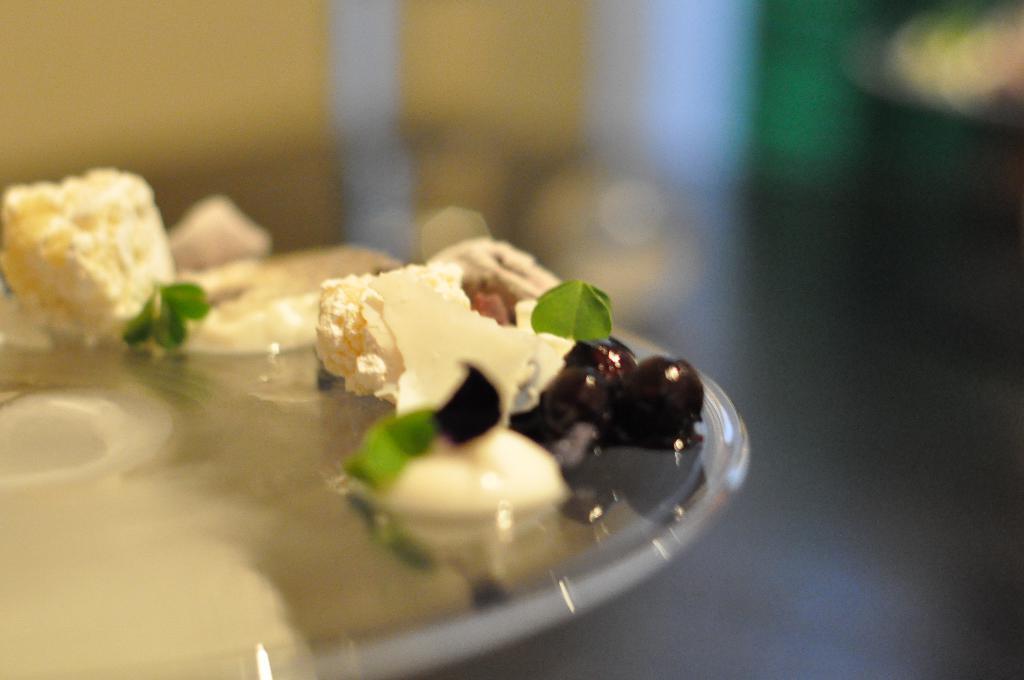Can you describe this image briefly? Here in this picture we can see a plate, on which we can see some fruits and sweets present over there. 